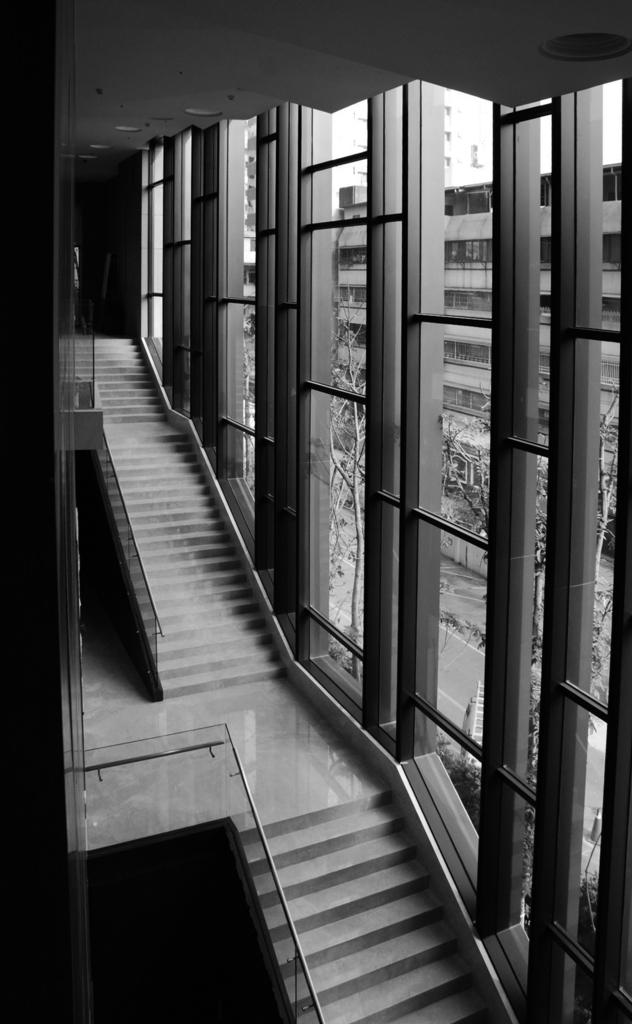What type of architectural feature is present in the image? There are stairs in the image. What can be seen on the right side of the image? There are glass windows on the right side of the image. What is visible through the glass windows? Trees and buildings are visible through the glass windows. What type of jeans is the family wearing in the image? There is no family or jeans present in the image. 